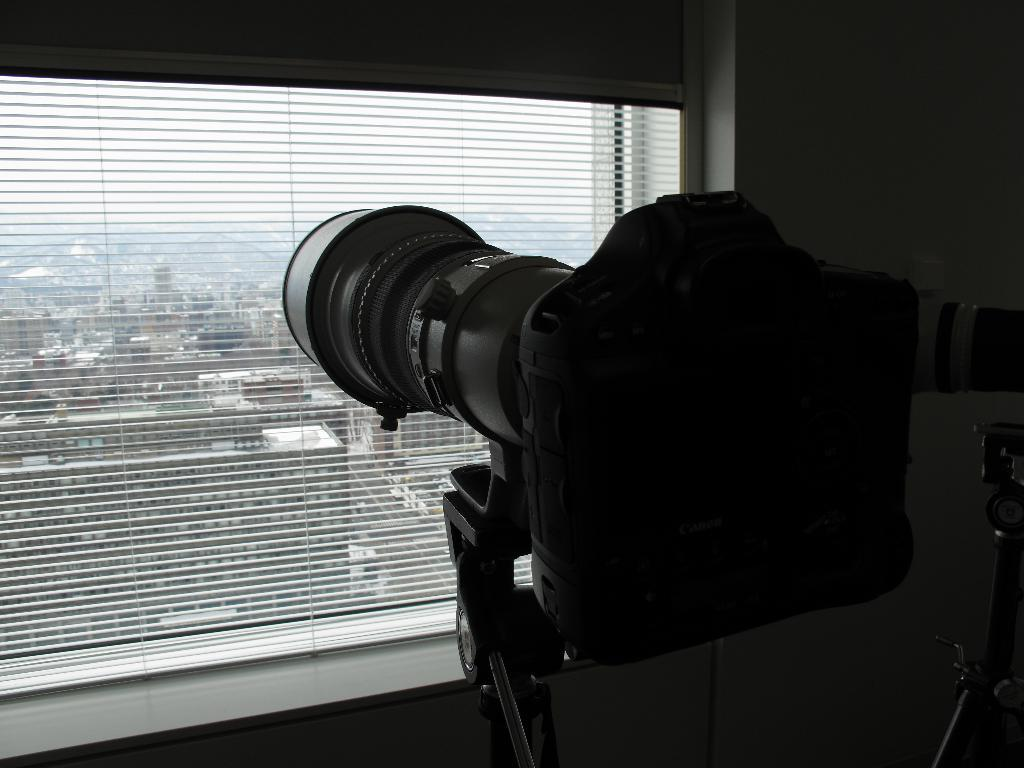What is the main subject in the center of the image? There is a camera in the center of the image. Where is the camera positioned in relation to the window? The camera is in front of a window. What can be seen outside the window? There are buildings visible outside the window. How many bulbs are attached to the camera in the image? There are no bulbs attached to the camera in the image. What type of bee can be seen buzzing around the camera in the image? There are no bees present in the image. 